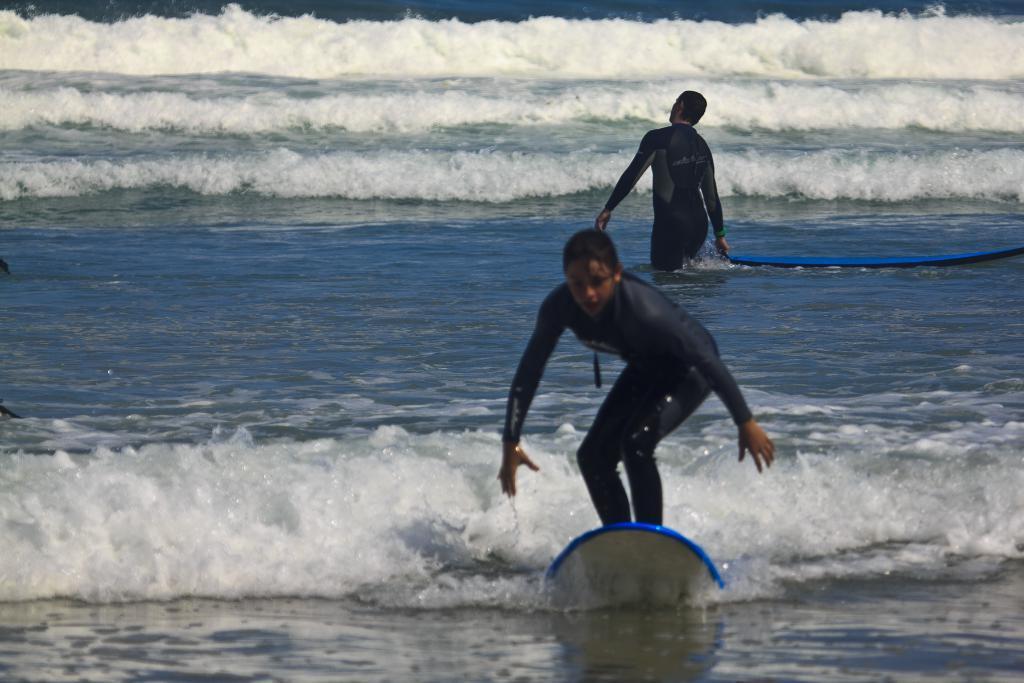Could you give a brief overview of what you see in this image? A woman is surfing on water behind her there is a person behind him there is a surf boat. 